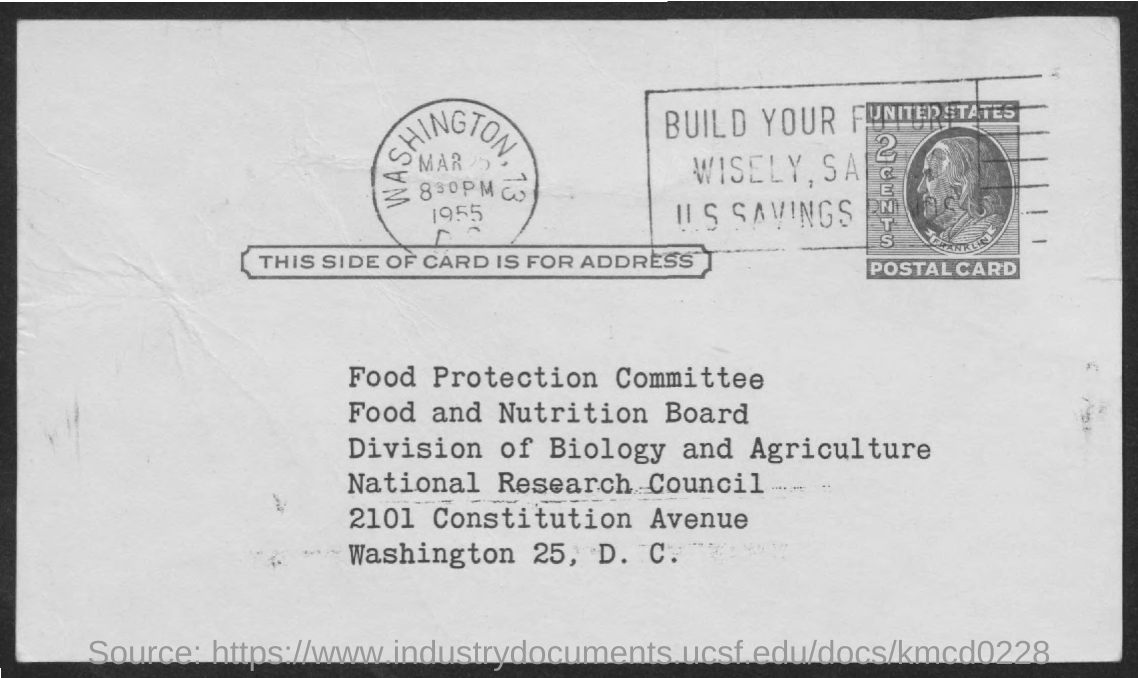Identify some key points in this picture. The year mentioned on the stamp is 1955. The name of the committee is the Food Protection Committee. The division mentioned in the given form is the Division of Biology and Agriculture. The postal stamp featured the name of the country that is known as the United States. The city name mentioned in the address is Washington. 